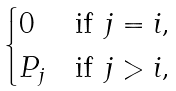Convert formula to latex. <formula><loc_0><loc_0><loc_500><loc_500>\begin{cases} 0 & \text {if $j=i$,} \\ P _ { j } & \text {if $j > i$,} \end{cases}</formula> 